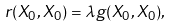Convert formula to latex. <formula><loc_0><loc_0><loc_500><loc_500>r ( X _ { 0 } , X _ { 0 } ) = \lambda g ( X _ { 0 } , X _ { 0 } ) ,</formula> 